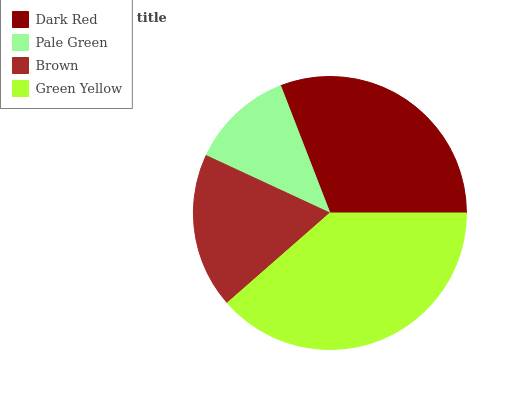Is Pale Green the minimum?
Answer yes or no. Yes. Is Green Yellow the maximum?
Answer yes or no. Yes. Is Brown the minimum?
Answer yes or no. No. Is Brown the maximum?
Answer yes or no. No. Is Brown greater than Pale Green?
Answer yes or no. Yes. Is Pale Green less than Brown?
Answer yes or no. Yes. Is Pale Green greater than Brown?
Answer yes or no. No. Is Brown less than Pale Green?
Answer yes or no. No. Is Dark Red the high median?
Answer yes or no. Yes. Is Brown the low median?
Answer yes or no. Yes. Is Green Yellow the high median?
Answer yes or no. No. Is Pale Green the low median?
Answer yes or no. No. 